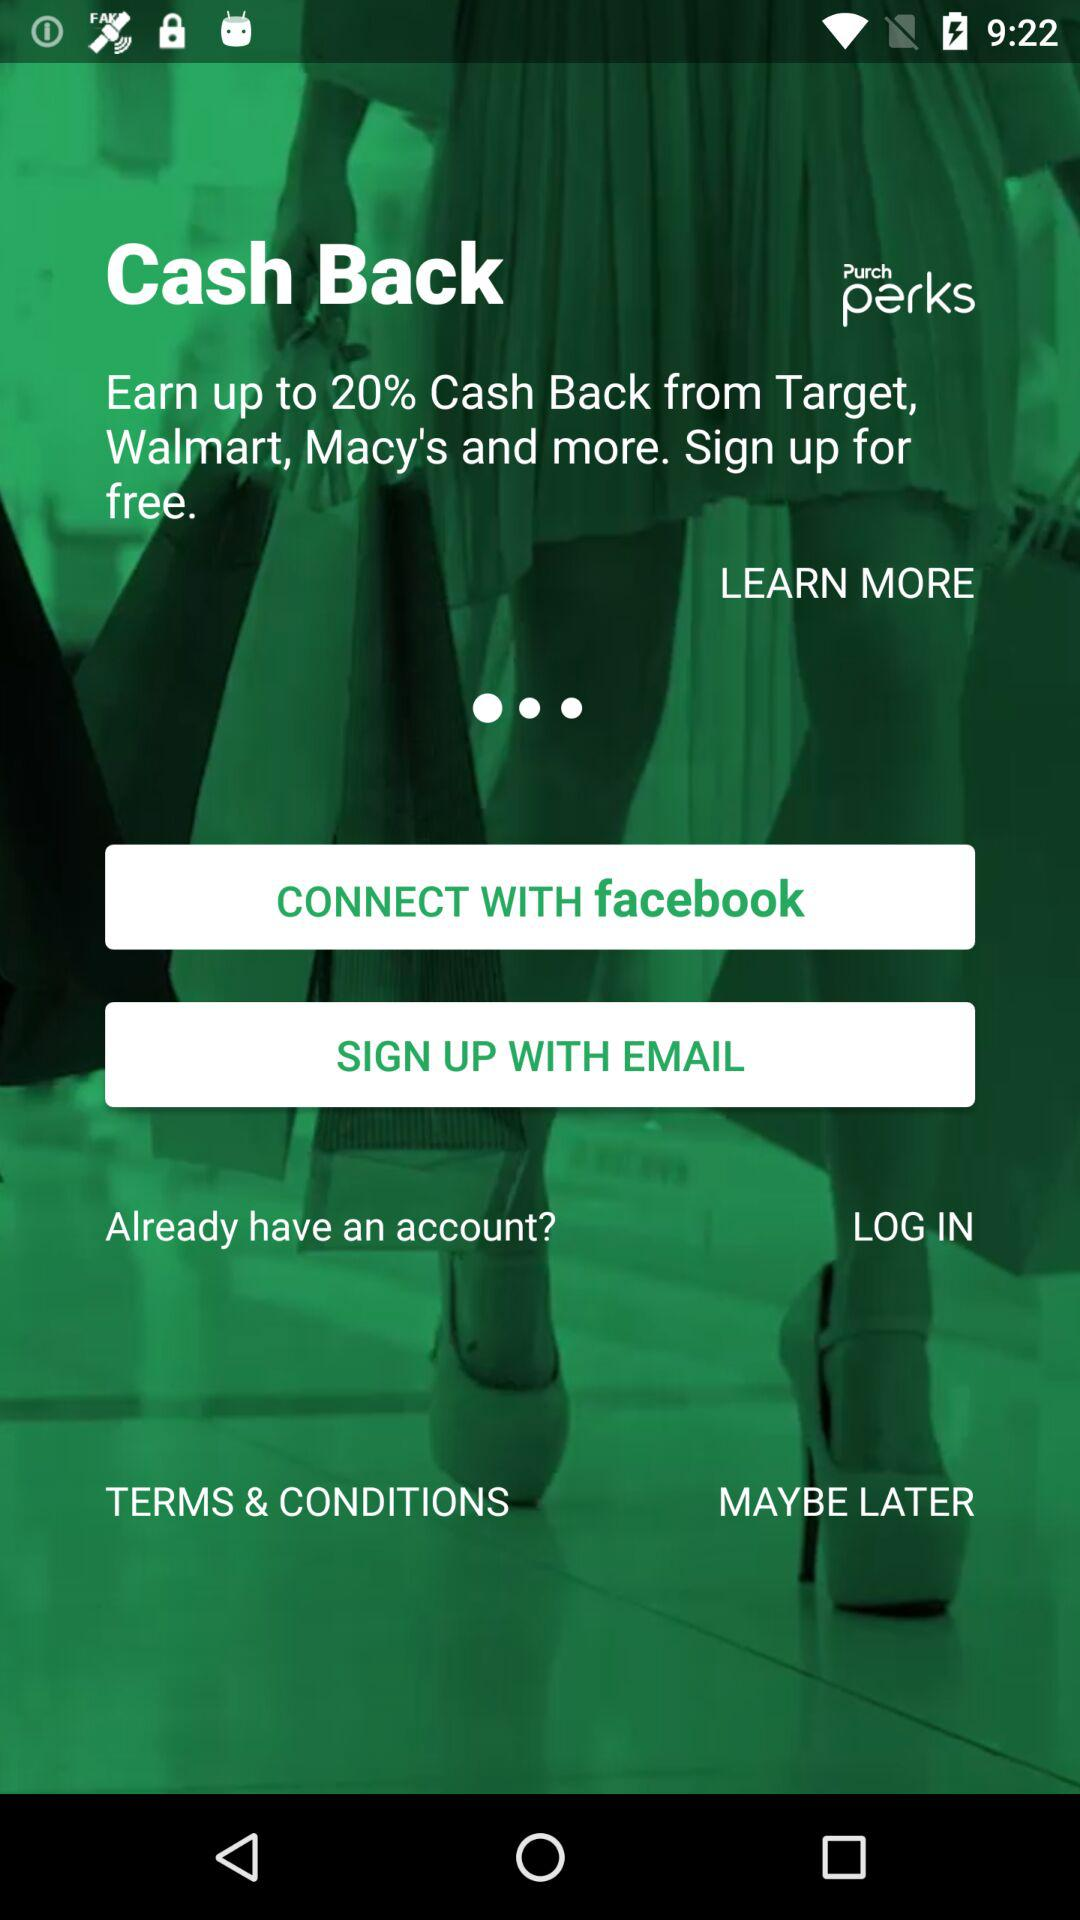What is the application name? The application name is "Purch perks". 